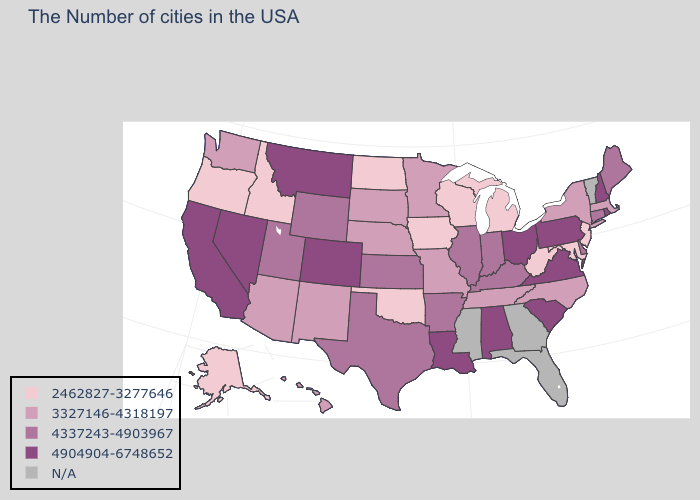Does Tennessee have the lowest value in the USA?
Answer briefly. No. Which states have the highest value in the USA?
Answer briefly. Rhode Island, New Hampshire, Pennsylvania, Virginia, South Carolina, Ohio, Alabama, Louisiana, Colorado, Montana, Nevada, California. Which states have the highest value in the USA?
Keep it brief. Rhode Island, New Hampshire, Pennsylvania, Virginia, South Carolina, Ohio, Alabama, Louisiana, Colorado, Montana, Nevada, California. Name the states that have a value in the range 2462827-3277646?
Give a very brief answer. New Jersey, Maryland, West Virginia, Michigan, Wisconsin, Iowa, Oklahoma, North Dakota, Idaho, Oregon, Alaska. What is the lowest value in the Northeast?
Keep it brief. 2462827-3277646. What is the highest value in states that border Oklahoma?
Write a very short answer. 4904904-6748652. Name the states that have a value in the range 2462827-3277646?
Concise answer only. New Jersey, Maryland, West Virginia, Michigan, Wisconsin, Iowa, Oklahoma, North Dakota, Idaho, Oregon, Alaska. What is the lowest value in states that border Indiana?
Give a very brief answer. 2462827-3277646. Does Wyoming have the highest value in the USA?
Write a very short answer. No. Does Iowa have the lowest value in the MidWest?
Write a very short answer. Yes. Is the legend a continuous bar?
Concise answer only. No. Name the states that have a value in the range 4904904-6748652?
Quick response, please. Rhode Island, New Hampshire, Pennsylvania, Virginia, South Carolina, Ohio, Alabama, Louisiana, Colorado, Montana, Nevada, California. How many symbols are there in the legend?
Concise answer only. 5. 